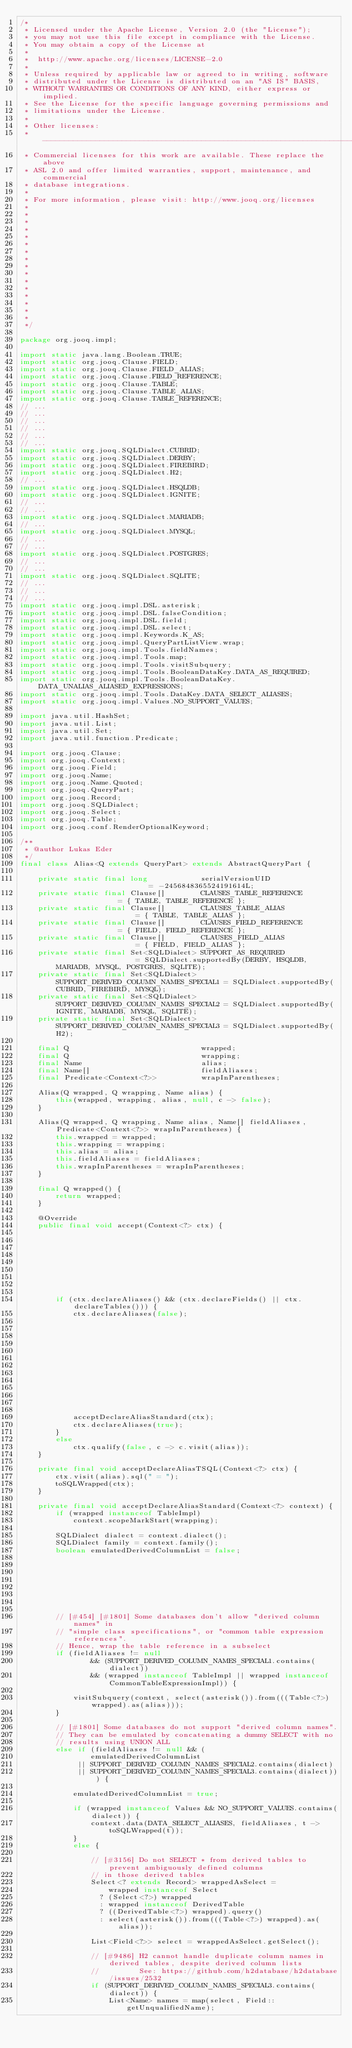<code> <loc_0><loc_0><loc_500><loc_500><_Java_>/*
 * Licensed under the Apache License, Version 2.0 (the "License");
 * you may not use this file except in compliance with the License.
 * You may obtain a copy of the License at
 *
 *  http://www.apache.org/licenses/LICENSE-2.0
 *
 * Unless required by applicable law or agreed to in writing, software
 * distributed under the License is distributed on an "AS IS" BASIS,
 * WITHOUT WARRANTIES OR CONDITIONS OF ANY KIND, either express or implied.
 * See the License for the specific language governing permissions and
 * limitations under the License.
 *
 * Other licenses:
 * -----------------------------------------------------------------------------
 * Commercial licenses for this work are available. These replace the above
 * ASL 2.0 and offer limited warranties, support, maintenance, and commercial
 * database integrations.
 *
 * For more information, please visit: http://www.jooq.org/licenses
 *
 *
 *
 *
 *
 *
 *
 *
 *
 *
 *
 *
 *
 *
 *
 *
 */

package org.jooq.impl;

import static java.lang.Boolean.TRUE;
import static org.jooq.Clause.FIELD;
import static org.jooq.Clause.FIELD_ALIAS;
import static org.jooq.Clause.FIELD_REFERENCE;
import static org.jooq.Clause.TABLE;
import static org.jooq.Clause.TABLE_ALIAS;
import static org.jooq.Clause.TABLE_REFERENCE;
// ...
// ...
// ...
// ...
// ...
// ...
import static org.jooq.SQLDialect.CUBRID;
import static org.jooq.SQLDialect.DERBY;
import static org.jooq.SQLDialect.FIREBIRD;
import static org.jooq.SQLDialect.H2;
// ...
import static org.jooq.SQLDialect.HSQLDB;
import static org.jooq.SQLDialect.IGNITE;
// ...
// ...
import static org.jooq.SQLDialect.MARIADB;
// ...
import static org.jooq.SQLDialect.MYSQL;
// ...
// ...
import static org.jooq.SQLDialect.POSTGRES;
// ...
// ...
import static org.jooq.SQLDialect.SQLITE;
// ...
// ...
// ...
import static org.jooq.impl.DSL.asterisk;
import static org.jooq.impl.DSL.falseCondition;
import static org.jooq.impl.DSL.field;
import static org.jooq.impl.DSL.select;
import static org.jooq.impl.Keywords.K_AS;
import static org.jooq.impl.QueryPartListView.wrap;
import static org.jooq.impl.Tools.fieldNames;
import static org.jooq.impl.Tools.map;
import static org.jooq.impl.Tools.visitSubquery;
import static org.jooq.impl.Tools.BooleanDataKey.DATA_AS_REQUIRED;
import static org.jooq.impl.Tools.BooleanDataKey.DATA_UNALIAS_ALIASED_EXPRESSIONS;
import static org.jooq.impl.Tools.DataKey.DATA_SELECT_ALIASES;
import static org.jooq.impl.Values.NO_SUPPORT_VALUES;

import java.util.HashSet;
import java.util.List;
import java.util.Set;
import java.util.function.Predicate;

import org.jooq.Clause;
import org.jooq.Context;
import org.jooq.Field;
import org.jooq.Name;
import org.jooq.Name.Quoted;
import org.jooq.QueryPart;
import org.jooq.Record;
import org.jooq.SQLDialect;
import org.jooq.Select;
import org.jooq.Table;
import org.jooq.conf.RenderOptionalKeyword;

/**
 * @author Lukas Eder
 */
final class Alias<Q extends QueryPart> extends AbstractQueryPart {

    private static final long            serialVersionUID                      = -2456848365524191614L;
    private static final Clause[]        CLAUSES_TABLE_REFERENCE               = { TABLE, TABLE_REFERENCE };
    private static final Clause[]        CLAUSES_TABLE_ALIAS                   = { TABLE, TABLE_ALIAS };
    private static final Clause[]        CLAUSES_FIELD_REFERENCE               = { FIELD, FIELD_REFERENCE };
    private static final Clause[]        CLAUSES_FIELD_ALIAS                   = { FIELD, FIELD_ALIAS };
    private static final Set<SQLDialect> SUPPORT_AS_REQUIRED                   = SQLDialect.supportedBy(DERBY, HSQLDB, MARIADB, MYSQL, POSTGRES, SQLITE);
    private static final Set<SQLDialect> SUPPORT_DERIVED_COLUMN_NAMES_SPECIAL1 = SQLDialect.supportedBy(CUBRID, FIREBIRD, MYSQL);
    private static final Set<SQLDialect> SUPPORT_DERIVED_COLUMN_NAMES_SPECIAL2 = SQLDialect.supportedBy(IGNITE, MARIADB, MYSQL, SQLITE);
    private static final Set<SQLDialect> SUPPORT_DERIVED_COLUMN_NAMES_SPECIAL3 = SQLDialect.supportedBy(H2);

    final Q                              wrapped;
    final Q                              wrapping;
    final Name                           alias;
    final Name[]                         fieldAliases;
    final Predicate<Context<?>>          wrapInParentheses;

    Alias(Q wrapped, Q wrapping, Name alias) {
        this(wrapped, wrapping, alias, null, c -> false);
    }

    Alias(Q wrapped, Q wrapping, Name alias, Name[] fieldAliases, Predicate<Context<?>> wrapInParentheses) {
        this.wrapped = wrapped;
        this.wrapping = wrapping;
        this.alias = alias;
        this.fieldAliases = fieldAliases;
        this.wrapInParentheses = wrapInParentheses;
    }

    final Q wrapped() {
        return wrapped;
    }

    @Override
    public final void accept(Context<?> ctx) {









        if (ctx.declareAliases() && (ctx.declareFields() || ctx.declareTables())) {
            ctx.declareAliases(false);













            acceptDeclareAliasStandard(ctx);
            ctx.declareAliases(true);
        }
        else
            ctx.qualify(false, c -> c.visit(alias));
    }

    private final void acceptDeclareAliasTSQL(Context<?> ctx) {
        ctx.visit(alias).sql(" = ");
        toSQLWrapped(ctx);
    }

    private final void acceptDeclareAliasStandard(Context<?> context) {
        if (wrapped instanceof TableImpl)
            context.scopeMarkStart(wrapping);

        SQLDialect dialect = context.dialect();
        SQLDialect family = context.family();
        boolean emulatedDerivedColumnList = false;








        // [#454] [#1801] Some databases don't allow "derived column names" in
        // "simple class specifications", or "common table expression references".
        // Hence, wrap the table reference in a subselect
        if (fieldAliases != null
                && (SUPPORT_DERIVED_COLUMN_NAMES_SPECIAL1.contains(dialect))
                && (wrapped instanceof TableImpl || wrapped instanceof CommonTableExpressionImpl)) {

            visitSubquery(context, select(asterisk()).from(((Table<?>) wrapped).as(alias)));
        }

        // [#1801] Some databases do not support "derived column names".
        // They can be emulated by concatenating a dummy SELECT with no
        // results using UNION ALL
        else if (fieldAliases != null && (
                emulatedDerivedColumnList
             || SUPPORT_DERIVED_COLUMN_NAMES_SPECIAL2.contains(dialect)
             || SUPPORT_DERIVED_COLUMN_NAMES_SPECIAL3.contains(dialect))) {

            emulatedDerivedColumnList = true;

            if (wrapped instanceof Values && NO_SUPPORT_VALUES.contains(dialect)) {
                context.data(DATA_SELECT_ALIASES, fieldAliases, t -> toSQLWrapped(t));
            }
            else {

                // [#3156] Do not SELECT * from derived tables to prevent ambiguously defined columns
                // in those derived tables
                Select<? extends Record> wrappedAsSelect =
                    wrapped instanceof Select
                  ? (Select<?>) wrapped
                  : wrapped instanceof DerivedTable
                  ? ((DerivedTable<?>) wrapped).query()
                  : select(asterisk()).from(((Table<?>) wrapped).as(alias));

                List<Field<?>> select = wrappedAsSelect.getSelect();

                // [#9486] H2 cannot handle duplicate column names in derived tables, despite derived column lists
                //         See: https://github.com/h2database/h2database/issues/2532
                if (SUPPORT_DERIVED_COLUMN_NAMES_SPECIAL3.contains(dialect)) {
                    List<Name> names = map(select, Field::getUnqualifiedName);
</code> 